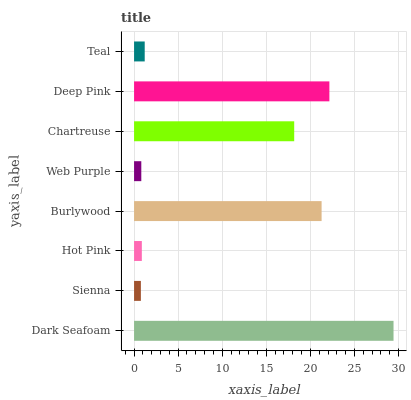Is Sienna the minimum?
Answer yes or no. Yes. Is Dark Seafoam the maximum?
Answer yes or no. Yes. Is Hot Pink the minimum?
Answer yes or no. No. Is Hot Pink the maximum?
Answer yes or no. No. Is Hot Pink greater than Sienna?
Answer yes or no. Yes. Is Sienna less than Hot Pink?
Answer yes or no. Yes. Is Sienna greater than Hot Pink?
Answer yes or no. No. Is Hot Pink less than Sienna?
Answer yes or no. No. Is Chartreuse the high median?
Answer yes or no. Yes. Is Teal the low median?
Answer yes or no. Yes. Is Sienna the high median?
Answer yes or no. No. Is Hot Pink the low median?
Answer yes or no. No. 